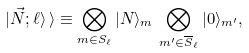<formula> <loc_0><loc_0><loc_500><loc_500>| \vec { N } ; \ell \rangle \, \rangle \equiv \bigotimes _ { m \in S _ { \ell } } | N \rangle _ { m } \, \bigotimes _ { m ^ { \prime } \in { \overline { S } _ { \ell } } } | 0 \rangle _ { m ^ { \prime } } ,</formula> 